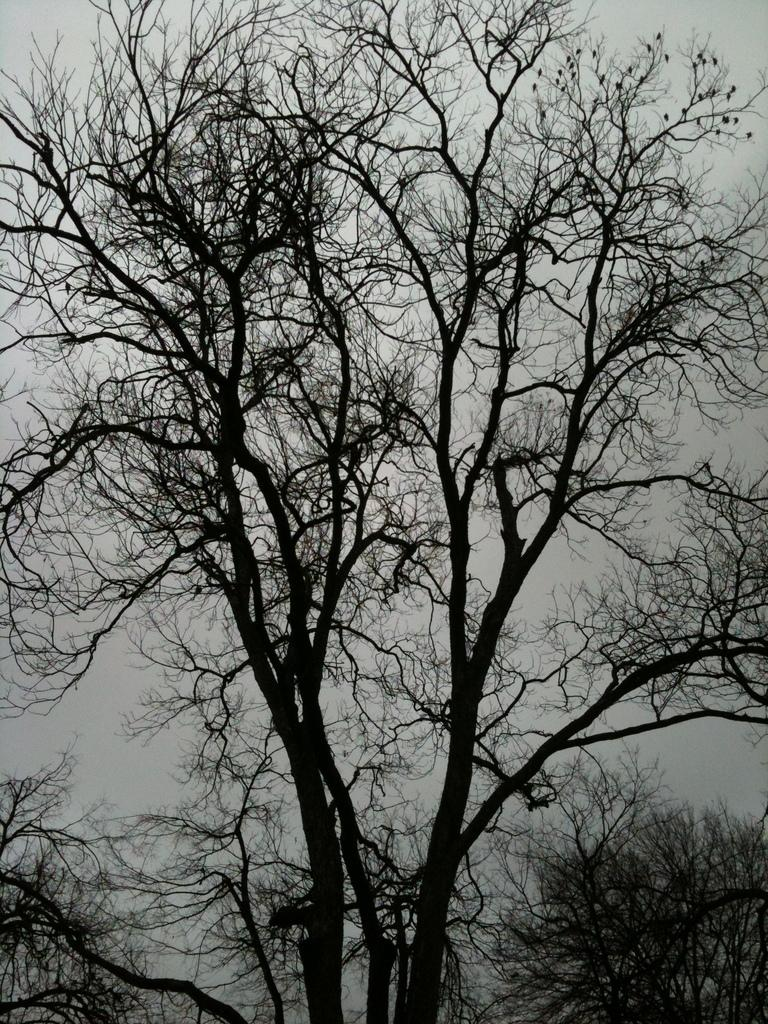What type of vegetation can be seen in the image? There are trees in the image. What part of the natural environment is visible in the image? The sky is visible in the background of the image. How many grapes are hanging from the trees in the image? There are no grapes visible in the image; the trees are not identified as fruit-bearing trees. 